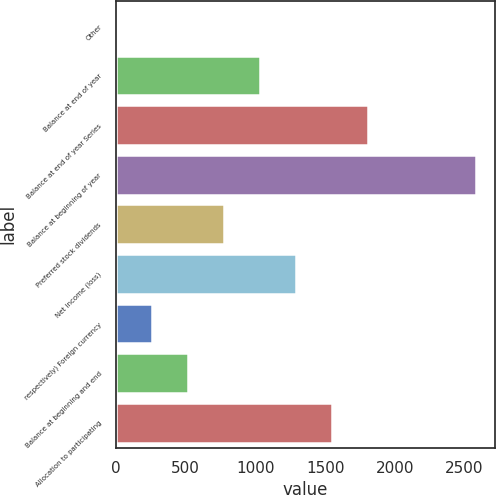Convert chart. <chart><loc_0><loc_0><loc_500><loc_500><bar_chart><fcel>Other<fcel>Balance at end of year<fcel>Balance at end of year Series<fcel>Balance at beginning of year<fcel>Preferred stock dividends<fcel>Net income (loss)<fcel>respectively) Foreign currency<fcel>Balance at beginning and end<fcel>Allocation to participating<nl><fcel>0.3<fcel>1034.66<fcel>1810.43<fcel>2586.2<fcel>776.07<fcel>1293.25<fcel>258.89<fcel>517.48<fcel>1551.84<nl></chart> 